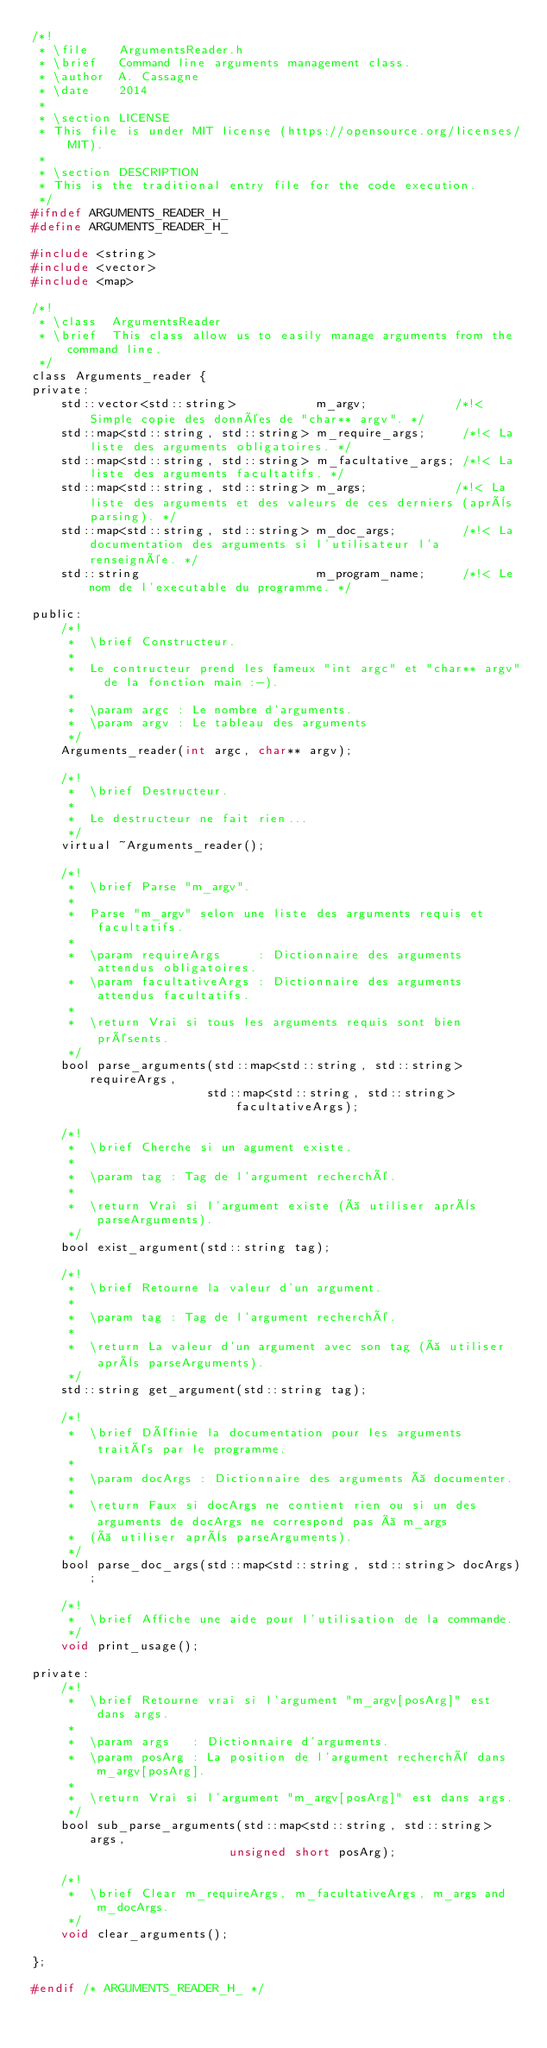<code> <loc_0><loc_0><loc_500><loc_500><_C_>/*!
 * \file    ArgumentsReader.h
 * \brief   Command line arguments management class.
 * \author  A. Cassagne
 * \date    2014
 *
 * \section LICENSE
 * This file is under MIT license (https://opensource.org/licenses/MIT).
 *
 * \section DESCRIPTION
 * This is the traditional entry file for the code execution.
 */
#ifndef ARGUMENTS_READER_H_
#define ARGUMENTS_READER_H_

#include <string>
#include <vector>
#include <map>

/*!
 * \class  ArgumentsReader
 * \brief  This class allow us to easily manage arguments from the command line.
 */
class Arguments_reader {
private:
	std::vector<std::string>           m_argv;            /*!< Simple copie des données de "char** argv". */
	std::map<std::string, std::string> m_require_args;     /*!< La liste des arguments obligatoires. */
	std::map<std::string, std::string> m_facultative_args; /*!< La liste des arguments facultatifs. */
	std::map<std::string, std::string> m_args;            /*!< La liste des arguments et des valeurs de ces derniers (après parsing). */
	std::map<std::string, std::string> m_doc_args;         /*!< La documentation des arguments si l'utilisateur l'a renseignée. */
	std::string                        m_program_name;     /*!< Le nom de l'executable du programme. */

public:
	/*!
	 *  \brief Constructeur.
	 *
	 *  Le contructeur prend les fameux "int argc" et "char** argv" de la fonction main :-).
	 *
	 *  \param argc : Le nombre d'arguments.
	 *  \param argv : Le tableau des arguments
	 */
	Arguments_reader(int argc, char** argv);

	/*!
	 *  \brief Destructeur.
	 *
	 *  Le destructeur ne fait rien...
	 */
	virtual ~Arguments_reader();

	/*!
	 *  \brief Parse "m_argv".
	 *
	 *  Parse "m_argv" selon une liste des arguments requis et facultatifs.
	 *
	 *  \param requireArgs     : Dictionnaire des arguments attendus obligatoires.
	 *  \param facultativeArgs : Dictionnaire des arguments attendus facultatifs.
	 *
	 *  \return Vrai si tous les arguments requis sont bien présents.
	 */
	bool parse_arguments(std::map<std::string, std::string> requireArgs,
	                    std::map<std::string, std::string> facultativeArgs);

	/*!
	 *  \brief Cherche si un agument existe.
	 *
	 *  \param tag : Tag de l'argument recherché.
	 *
	 *  \return Vrai si l'argument existe (à utiliser après parseArguments).
	 */
	bool exist_argument(std::string tag);

	/*!
	 *  \brief Retourne la valeur d'un argument.
	 *
	 *  \param tag : Tag de l'argument recherché.
	 *
	 *  \return La valeur d'un argument avec son tag (à utiliser après parseArguments).
	 */
	std::string get_argument(std::string tag);

	/*!
	 *  \brief Définie la documentation pour les arguments traités par le programme.
	 *
	 *  \param docArgs : Dictionnaire des arguments à documenter.
	 *
	 *  \return Faux si docArgs ne contient rien ou si un des arguments de docArgs ne correspond pas à m_args
	 *  (à utiliser après parseArguments).
	 */
	bool parse_doc_args(std::map<std::string, std::string> docArgs);

	/*!
	 *  \brief Affiche une aide pour l'utilisation de la commande.
	 */
	void print_usage();

private:
	/*!
	 *  \brief Retourne vrai si l'argument "m_argv[posArg]" est dans args.
	 *
	 *  \param args   : Dictionnaire d'arguments.
	 *  \param posArg : La position de l'argument recherché dans m_argv[posArg].
	 *
	 *  \return Vrai si l'argument "m_argv[posArg]" est dans args.
	 */
	bool sub_parse_arguments(std::map<std::string, std::string> args,
	                       unsigned short posArg);

	/*!
	 *  \brief Clear m_requireArgs, m_facultativeArgs, m_args and m_docArgs.
	 */
	void clear_arguments();

};

#endif /* ARGUMENTS_READER_H_ */
</code> 